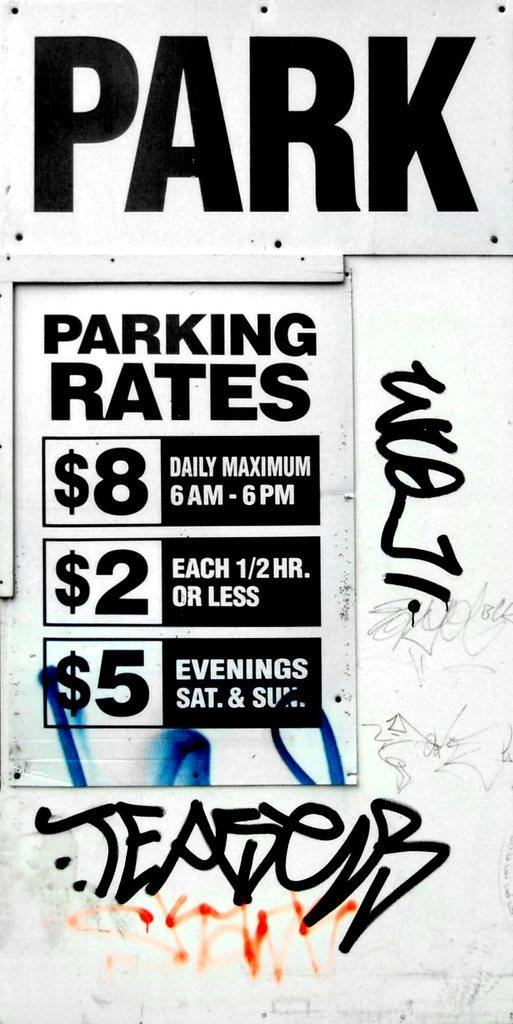<image>
Offer a succinct explanation of the picture presented. A black and white sign that lists parking rates and parking times. 